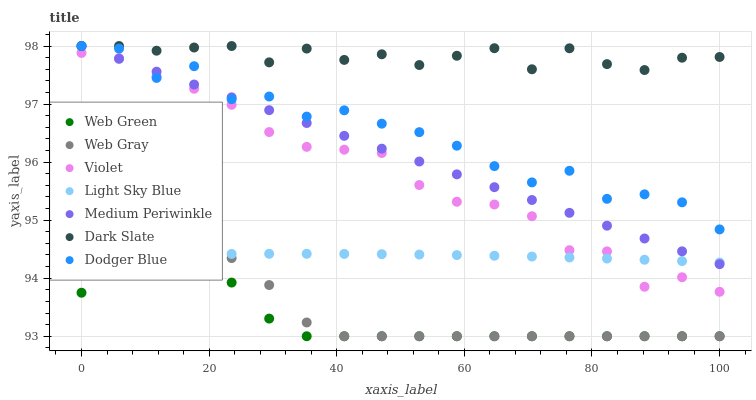Does Web Green have the minimum area under the curve?
Answer yes or no. Yes. Does Dark Slate have the maximum area under the curve?
Answer yes or no. Yes. Does Medium Periwinkle have the minimum area under the curve?
Answer yes or no. No. Does Medium Periwinkle have the maximum area under the curve?
Answer yes or no. No. Is Medium Periwinkle the smoothest?
Answer yes or no. Yes. Is Dodger Blue the roughest?
Answer yes or no. Yes. Is Web Green the smoothest?
Answer yes or no. No. Is Web Green the roughest?
Answer yes or no. No. Does Web Gray have the lowest value?
Answer yes or no. Yes. Does Medium Periwinkle have the lowest value?
Answer yes or no. No. Does Dodger Blue have the highest value?
Answer yes or no. Yes. Does Web Green have the highest value?
Answer yes or no. No. Is Violet less than Dark Slate?
Answer yes or no. Yes. Is Dodger Blue greater than Light Sky Blue?
Answer yes or no. Yes. Does Medium Periwinkle intersect Dodger Blue?
Answer yes or no. Yes. Is Medium Periwinkle less than Dodger Blue?
Answer yes or no. No. Is Medium Periwinkle greater than Dodger Blue?
Answer yes or no. No. Does Violet intersect Dark Slate?
Answer yes or no. No. 